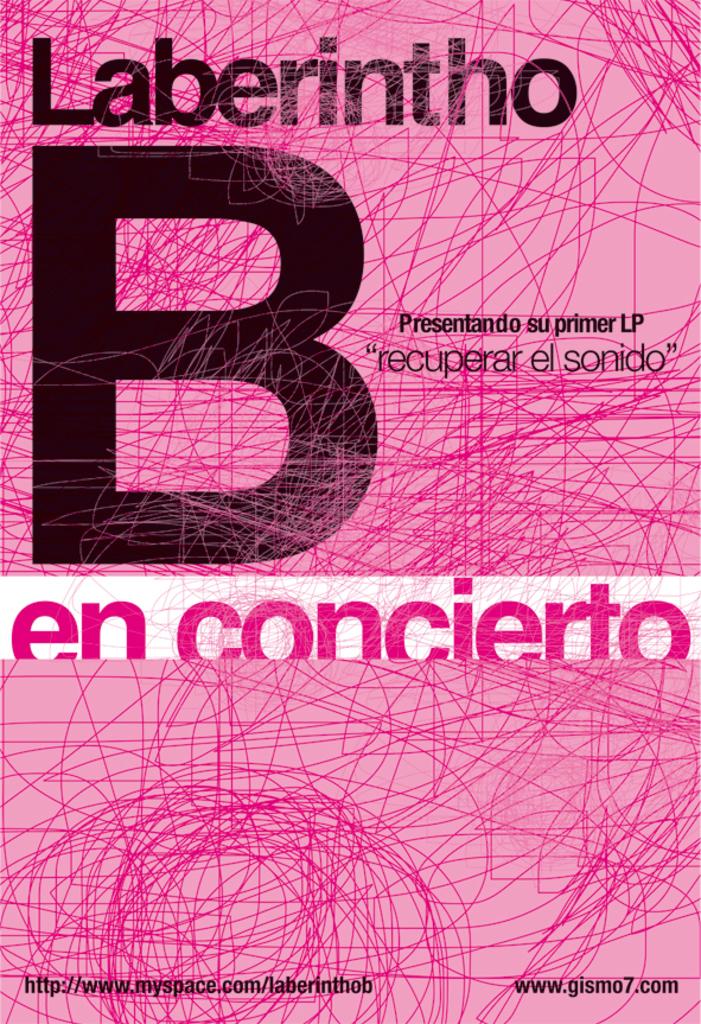What is the name of this book?
Your answer should be very brief. Laberintho b en concierto. What giant letter is printed on this book cover?
Your answer should be very brief. B. 